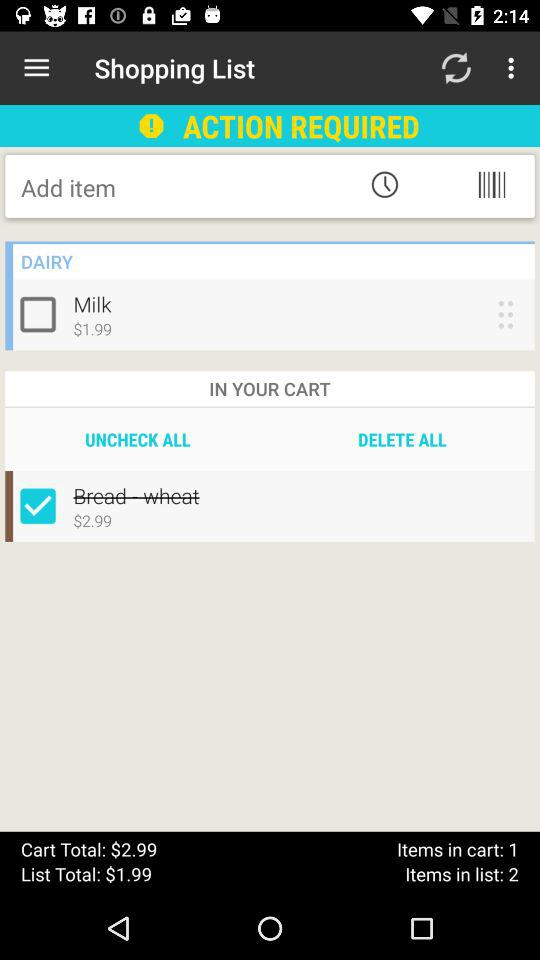How many items are there in your shopping cart? There is 1 item in your shopping cart. 